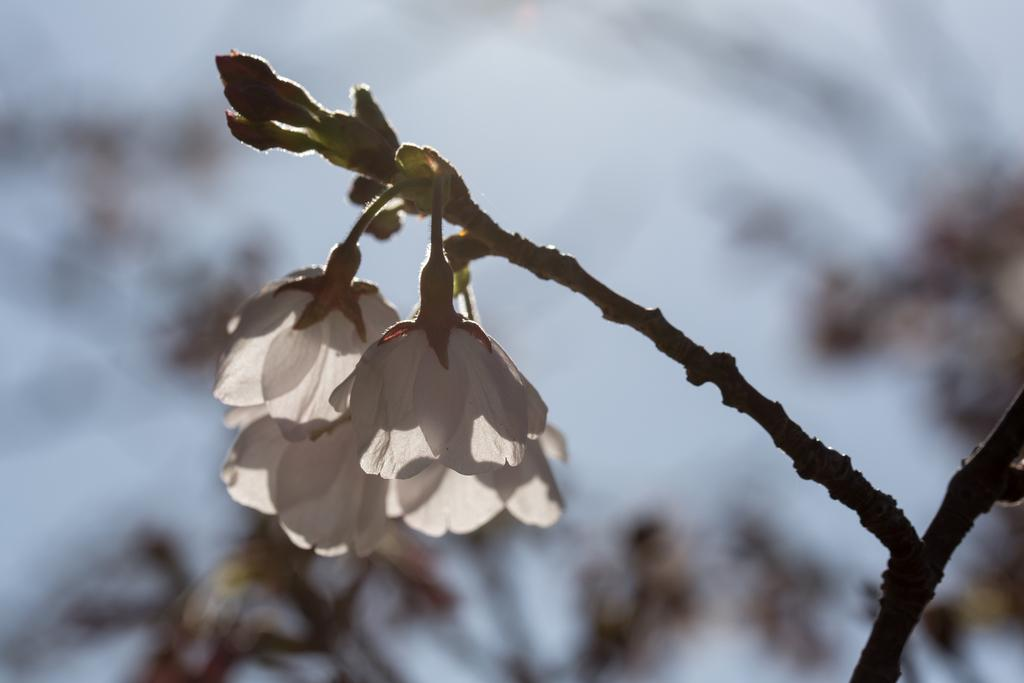What is the main subject of the image? The main subject of the image is a group of flowers on a stem. Can you describe the flowers in the image? The flowers are on a single stem. What else can be seen in the image? There are several plants in the background of the image. What type of gun is the daughter holding in the image? There is no daughter or gun present in the image; it features a group of flowers on a stem and plants in the background. 